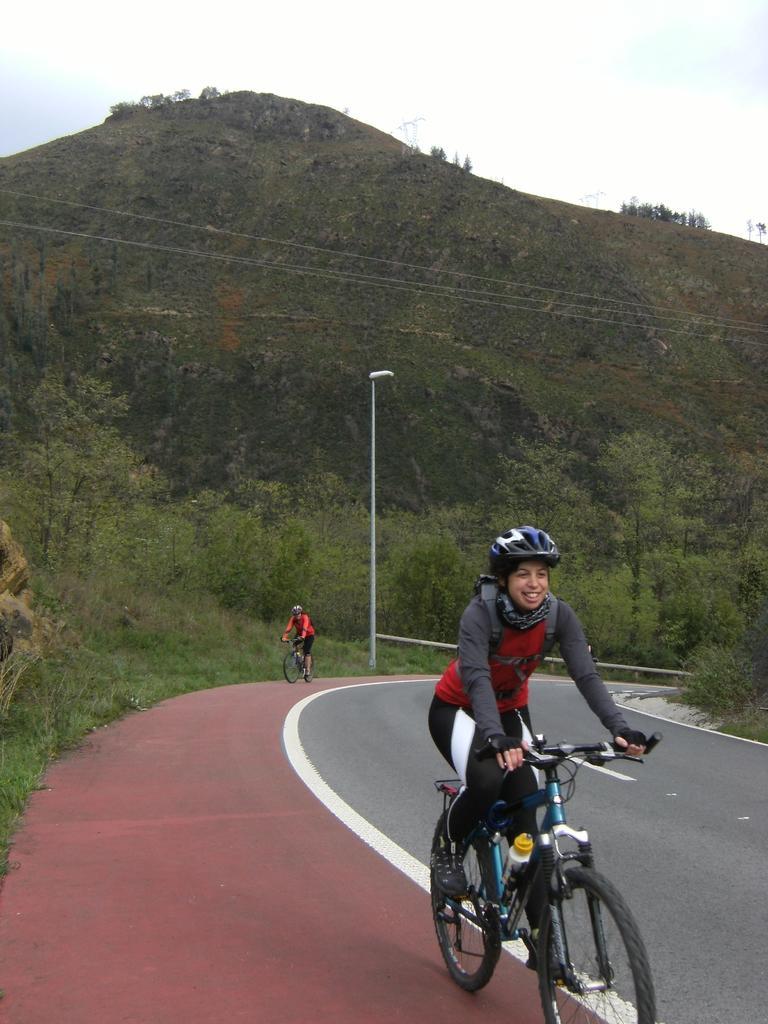Could you give a brief overview of what you see in this image? In this image we can see persons cycling on the road. In the background we can see pole, trees, hill and sky. 